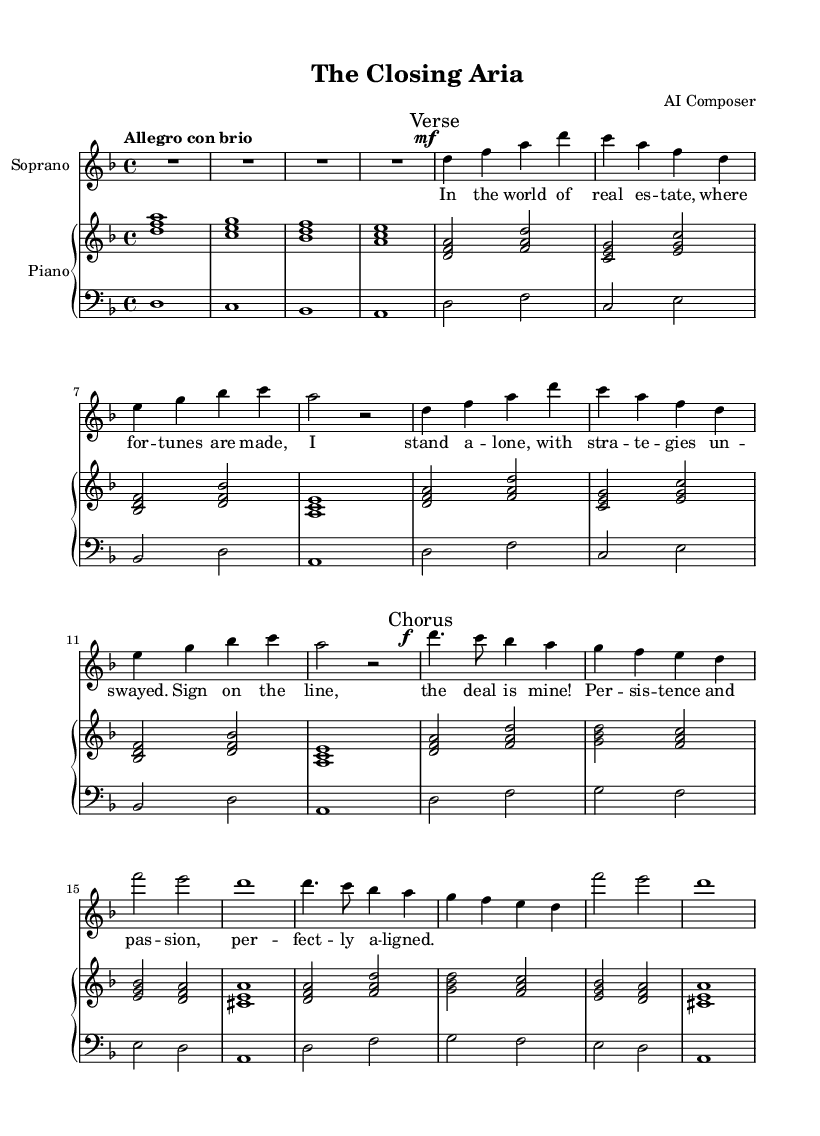What is the key signature of this music? The key signature indicated in the music is D minor, which has one flat (B flat).
Answer: D minor What is the time signature of this piece? The time signature shown in the music is 4/4, indicating four beats per measure.
Answer: 4/4 What is the tempo marking for this piece? The tempo marking specified is "Allegro con brio," which means fast and with vigor.
Answer: Allegro con brio How many measures are in the verse section? Counting the measures from the verse section, there are a total of 8 measures in that part of the sheet music.
Answer: 8 measures What dynamic marking is used at the beginning of the chorus? The dynamic marking at the beginning of the chorus is marked as forte, indicated by the 'f' symbol.
Answer: forte What is the primary theme of the lyrics? The lyrics' central theme revolves around successfully closing high-stakes real estate deals through persistence and passion.
Answer: Closing deals How many lines of lyrics are present in the first verse? The first verse contains a total of four lines of lyrics as indicated in the sheet music.
Answer: 4 lines 